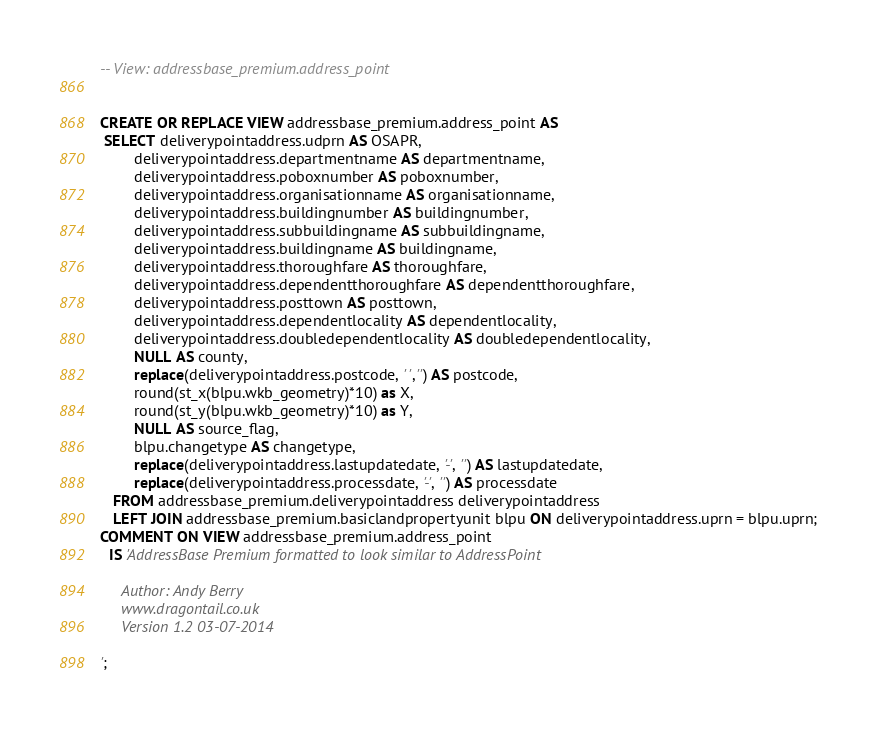Convert code to text. <code><loc_0><loc_0><loc_500><loc_500><_SQL_>-- View: addressbase_premium.address_point


CREATE OR REPLACE VIEW addressbase_premium.address_point AS
 SELECT deliverypointaddress.udprn AS OSAPR,
		deliverypointaddress.departmentname AS departmentname,
		deliverypointaddress.poboxnumber AS poboxnumber,
		deliverypointaddress.organisationname AS organisationname,
		deliverypointaddress.buildingnumber AS buildingnumber,
		deliverypointaddress.subbuildingname AS subbuildingname,
		deliverypointaddress.buildingname AS buildingname,
		deliverypointaddress.thoroughfare AS thoroughfare,
		deliverypointaddress.dependentthoroughfare AS dependentthoroughfare,
		deliverypointaddress.posttown AS posttown,
		deliverypointaddress.dependentlocality AS dependentlocality,
		deliverypointaddress.doubledependentlocality AS doubledependentlocality,
		NULL AS county,
		replace(deliverypointaddress.postcode, ' ','') AS postcode,
		round(st_x(blpu.wkb_geometry)*10) as X,
		round(st_y(blpu.wkb_geometry)*10) as Y,
		NULL AS source_flag,
		blpu.changetype AS changetype,
		replace(deliverypointaddress.lastupdatedate, '-', '') AS lastupdatedate,
		replace(deliverypointaddress.processdate, '-', '') AS processdate
   FROM addressbase_premium.deliverypointaddress deliverypointaddress
   LEFT JOIN addressbase_premium.basiclandpropertyunit blpu ON deliverypointaddress.uprn = blpu.uprn;
COMMENT ON VIEW addressbase_premium.address_point
  IS 'AddressBase Premium formatted to look similar to AddressPoint

     Author: Andy Berry
     www.dragontail.co.uk
     Version 1.2 03-07-2014

';

</code> 